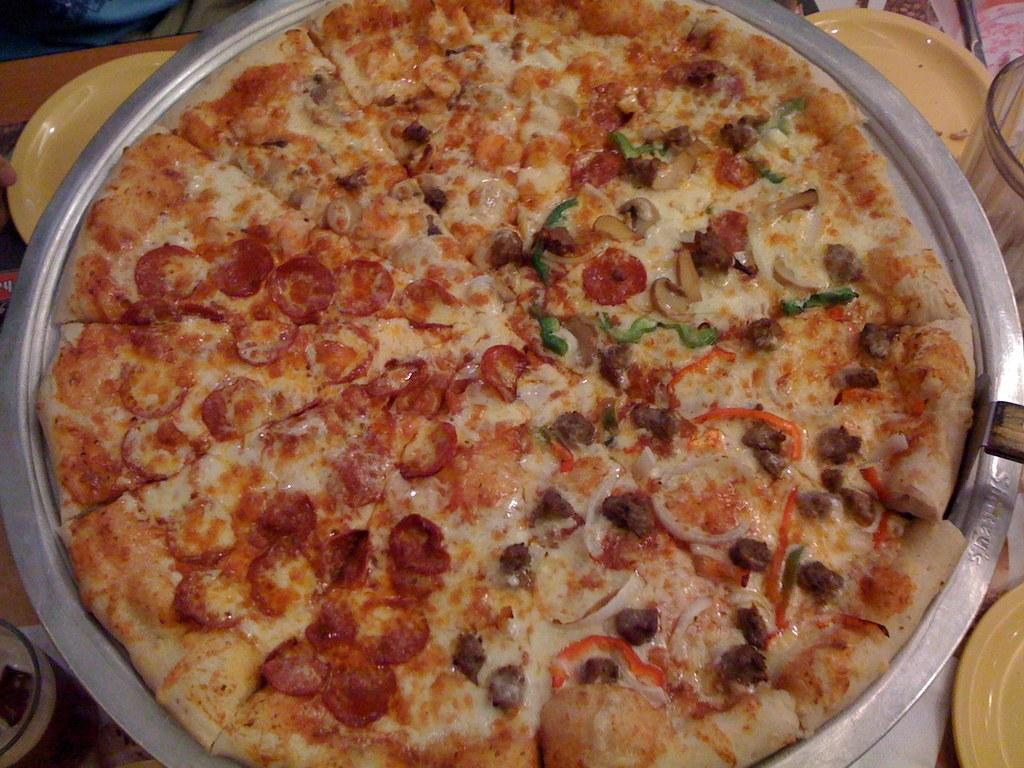What is on the plate that is visible in the image? There is pizza on the plate in the image. What other items can be seen in the image besides the plate? There are bowls visible in the image. What might be used for serving food in the image? The plate and bowls can be used for serving food in the image. What type of vegetable is being attacked by a carriage in the image? There is no vegetable or carriage present in the image. 